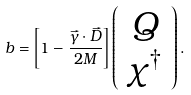Convert formula to latex. <formula><loc_0><loc_0><loc_500><loc_500>b = \left [ 1 - \frac { \vec { \gamma } \cdot \vec { D } } { 2 M } \right ] \left ( \begin{array} { c } Q \\ \chi ^ { \dag } \end{array} \right ) .</formula> 